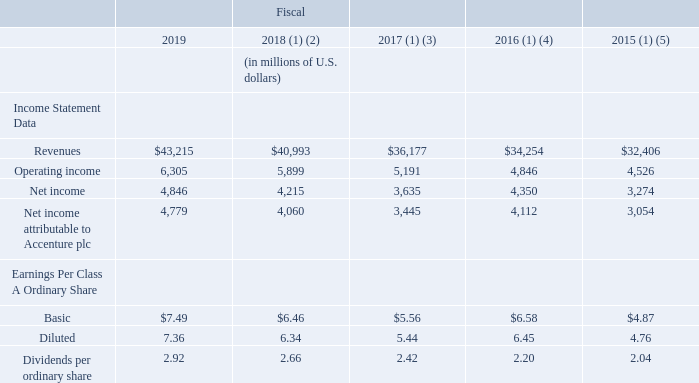ITEM 6. SELECTED FINANCIAL DATA
The data for fiscal 2019, 2018 and 2017 and as of August 31, 2019 and 2018 are derived from the audited Consolidated Financial Statements and related Notes that are included elsewhere in this report. The data for fiscal 2016 and 2015 and as of August 31, 2017, 2016 and 2015 are derived from the audited Consolidated Financial Statements and related Notes that are not included in this report. The selected financial data should be read in conjunction with “Management’s Discussion and Analysis of Financial Condition and Results of Operations” and our Consolidated Financial Statements and related Notes included elsewhere in this report.
(1) Effective September 1, 2018, we adopted FASB ASU No. 2014-09, Revenue from Contracts with Customers (Topic 606) and eliminated our net revenues presentation and FASB ASU No. 2017-07, Compensation-Retirement Benefits (Topic 715): Improving the Presentation of Net Periodic Pension Cost and Net Periodic Postretirement Benefit Cost. Prior period amounts have been revised to conform with the current period presentation.
(2) Includes the impact of a $258 million charge associated with tax law changes recorded during fiscal 2018. See “Management’s Discussion and Analysis of Financial Condition and Results of Operations—Results of Operations for Fiscal 2018 Compared to Fiscal 2017—Provision for Income Taxes.”
(3) Includes the impact of a $312 million, post-tax, pension settlement charge recorded during fiscal 2017. See “Management’s Discussion and Analysis of Financial Condition and Results of Operations—Results of Operations for Fiscal 2018 Compared to Fiscal 2017—Pension Settlement Charge.”
(4) Includes the impact of a $745 million, post-tax, gain on sale of businesses recorded during fiscal 2016.
(5) Includes the impact of a $39 million, post-tax, pension settlement charge recorded during fiscal 2015.
Between 2015 to 2019, which year did Accenture earn the highest revenue? 2019. What is the financial impact of the post-tax, pension settlement charge recorded during fiscal 2015？ $39 million. What is the company's net income attributable to Accenture plc in 2017?
Answer scale should be: million. 3,445. What is the post-tax, gain on sale of businesses recorded during fiscal 2016?
Answer scale should be: million. 745. What is the average revenue from 2015 to t2019?
Answer scale should be: million. (43,215 +40,993+36,177+34,254+32,406)/5 
Answer: 37409. What is the total dividends per ordinary share in 2018 and 2019?  $2.92 + $2.66 
Answer: 5.58. 